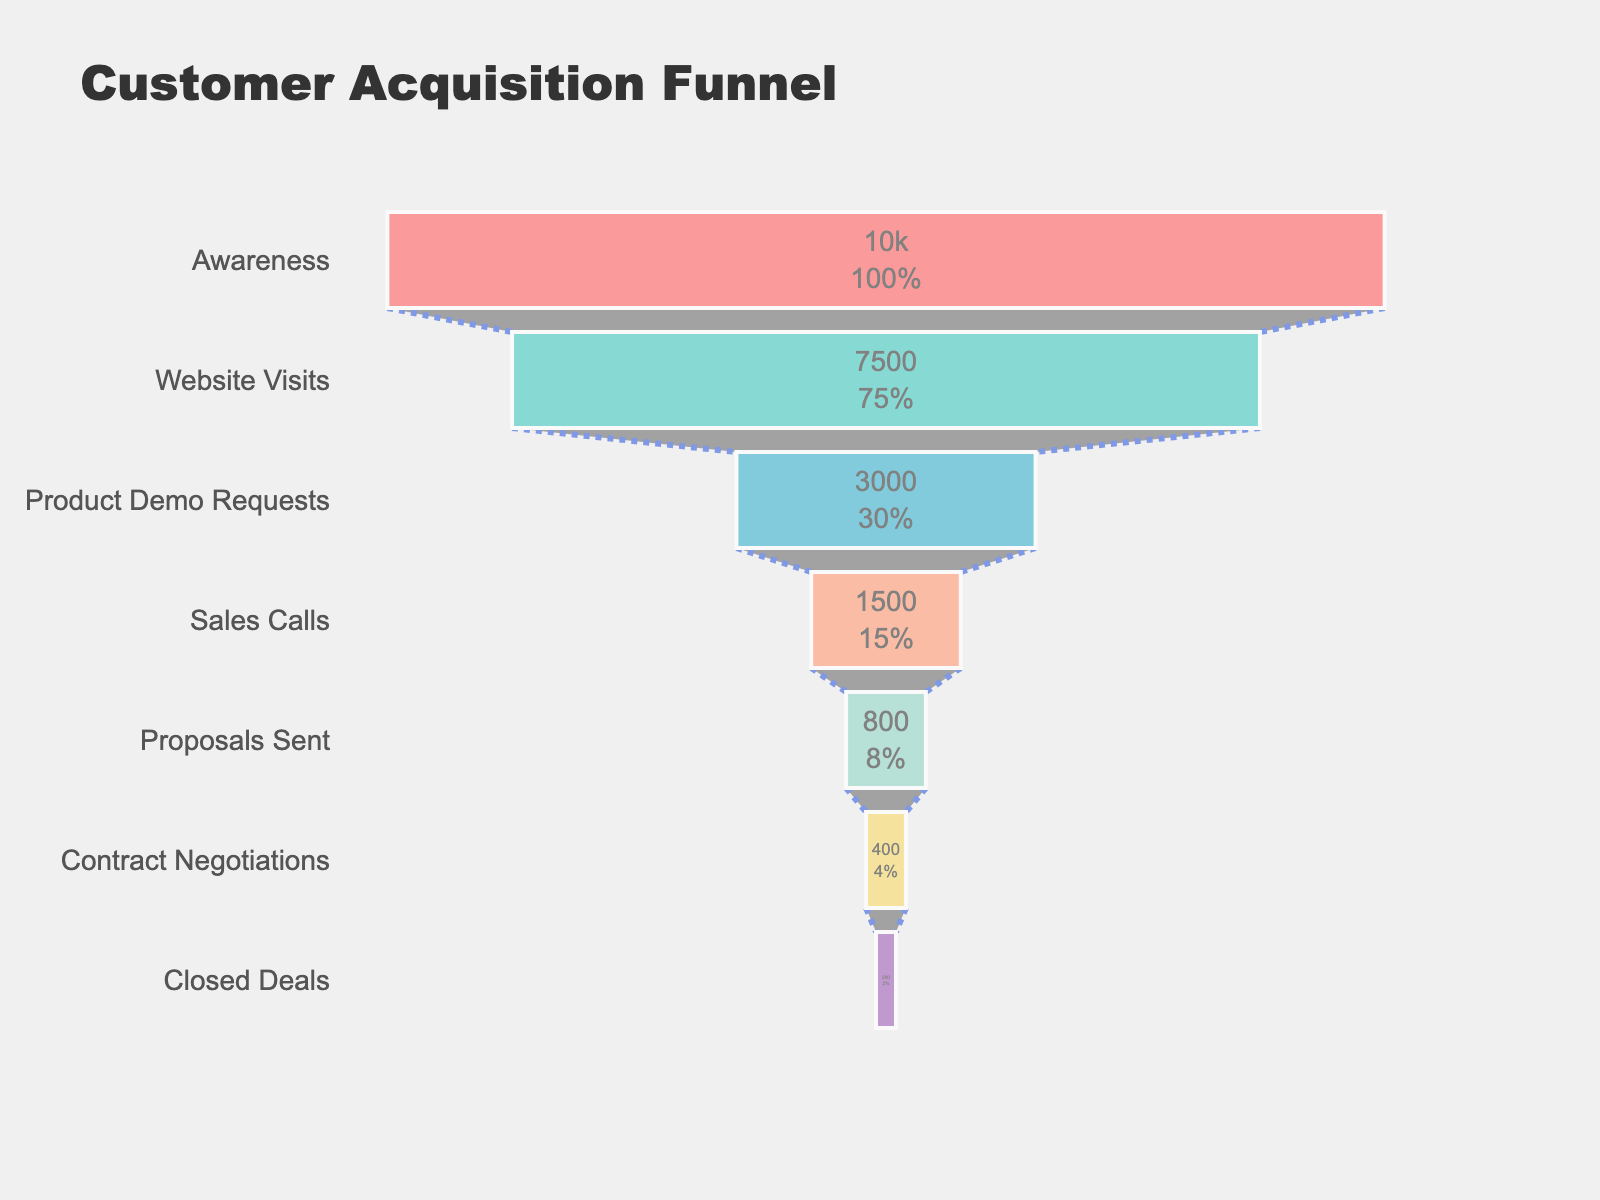How many stages are represented in the funnel chart? To find the number of stages, count the unique stages listed on the y-axis. In this case, the stages are Awareness, Website Visits, Product Demo Requests, Sales Calls, Proposals Sent, Contract Negotiations, and Closed Deals.
Answer: 7 What percentage of the initial customer base goes from Awareness to Closed Deals? First, we identify the counts at the Awareness and Closed Deals stages (10000 and 200 respectively). The percentage is calculated as (Closed Deals / Awareness) * 100, which is (200 / 10000) * 100.
Answer: 2% Which stage sees the largest drop in the number of customers? To determine the largest drop, subtract the customer counts between consecutive stages. The largest difference is between Product Demo Requests (3000) and Sales Calls (1500), a drop of 1500.
Answer: Product Demo Requests to Sales Calls How many customers requested a product demo? From the figure, locate the count corresponding to the stage "Product Demo Requests." The number is 3000.
Answer: 3000 What's the total number of customers who drop out between the Awareness stage and the Sales Calls stage? Sum the drops between Awareness and Sales Calls. Subtract the count at each stage from the previous stage: (10000 - 7500) + (7500 - 3000) + (3000 - 1500).
Answer: 7000 Which color represents the Sales Calls stage in the funnel chart? Follow the color gradient in the funnel chart. The Sales Calls stage is colored in a light orange shade.
Answer: light orange Is the count of Closed Deals half the count of Contract Negotiations? Compare the counts at Closed Deals (200) and Contract Negotiations (400). 200 is indeed half of 400.
Answer: yes What’s the difference in customer count between the Proposals Sent stage and the Closed Deals stage? Subtract the count at Closed Deals from the count at Proposals Sent: 800 - 200.
Answer: 600 Between which two consecutive stages is the percentage drop the smallest? Calculate the percentage drop between all consecutive stages and compare: Awareness to Website Visits (25%), Website Visits to Product Demo Requests (60%), Product Demo Requests to Sales Calls (50%), Sales Calls to Proposals Sent (46.67%), Proposals Sent to Contract Negotiations (50%), Contract Negotiations to Closed Deals (50%). The smallest drop is from Sales Calls to Proposals Sent.
Answer: Sales Calls to Proposals Sent What is the initial percentage of customers who visit the website after being aware of the product? Calculate the percentage as (Website Visits / Awareness) * 100, which is (7500 / 10000) * 100.
Answer: 75% 